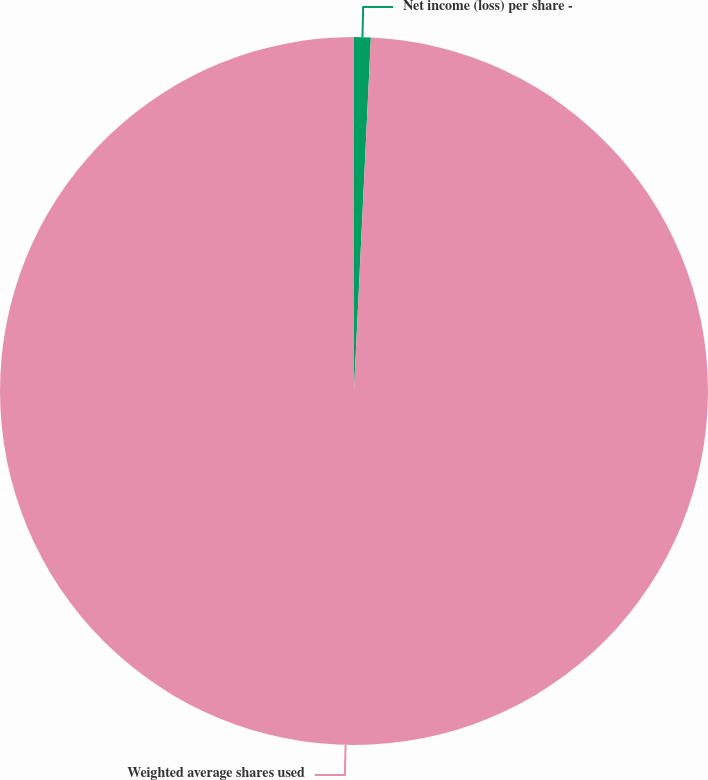Convert chart to OTSL. <chart><loc_0><loc_0><loc_500><loc_500><pie_chart><fcel>Net income (loss) per share -<fcel>Weighted average shares used<nl><fcel>0.76%<fcel>99.24%<nl></chart> 